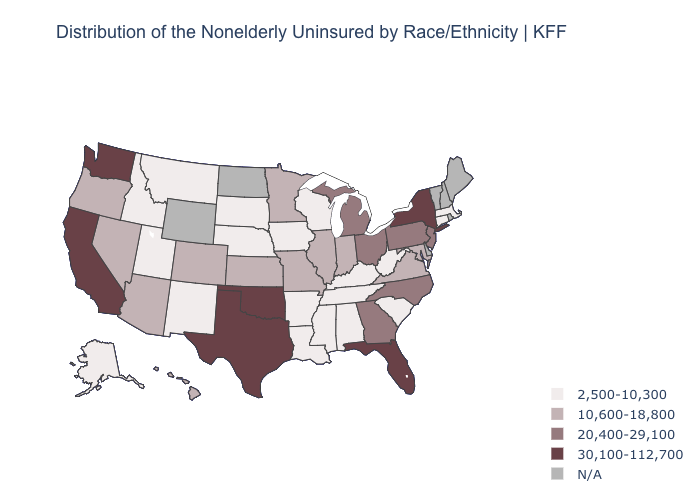Which states have the lowest value in the Northeast?
Short answer required. Connecticut, Massachusetts. What is the value of Maine?
Keep it brief. N/A. Name the states that have a value in the range 20,400-29,100?
Short answer required. Georgia, Michigan, New Jersey, North Carolina, Ohio, Pennsylvania. Which states have the lowest value in the USA?
Short answer required. Alabama, Alaska, Arkansas, Connecticut, Idaho, Iowa, Kentucky, Louisiana, Massachusetts, Mississippi, Montana, Nebraska, New Mexico, South Carolina, South Dakota, Tennessee, Utah, West Virginia, Wisconsin. Name the states that have a value in the range 10,600-18,800?
Be succinct. Arizona, Colorado, Hawaii, Illinois, Indiana, Kansas, Maryland, Minnesota, Missouri, Nevada, Oregon, Virginia. Among the states that border Texas , does Oklahoma have the highest value?
Quick response, please. Yes. Among the states that border Nevada , does Oregon have the highest value?
Give a very brief answer. No. What is the lowest value in states that border Connecticut?
Keep it brief. 2,500-10,300. Does Colorado have the highest value in the USA?
Be succinct. No. What is the value of Nevada?
Keep it brief. 10,600-18,800. What is the value of Rhode Island?
Write a very short answer. N/A. What is the lowest value in the USA?
Answer briefly. 2,500-10,300. Does Ohio have the highest value in the MidWest?
Write a very short answer. Yes. Name the states that have a value in the range 20,400-29,100?
Be succinct. Georgia, Michigan, New Jersey, North Carolina, Ohio, Pennsylvania. 